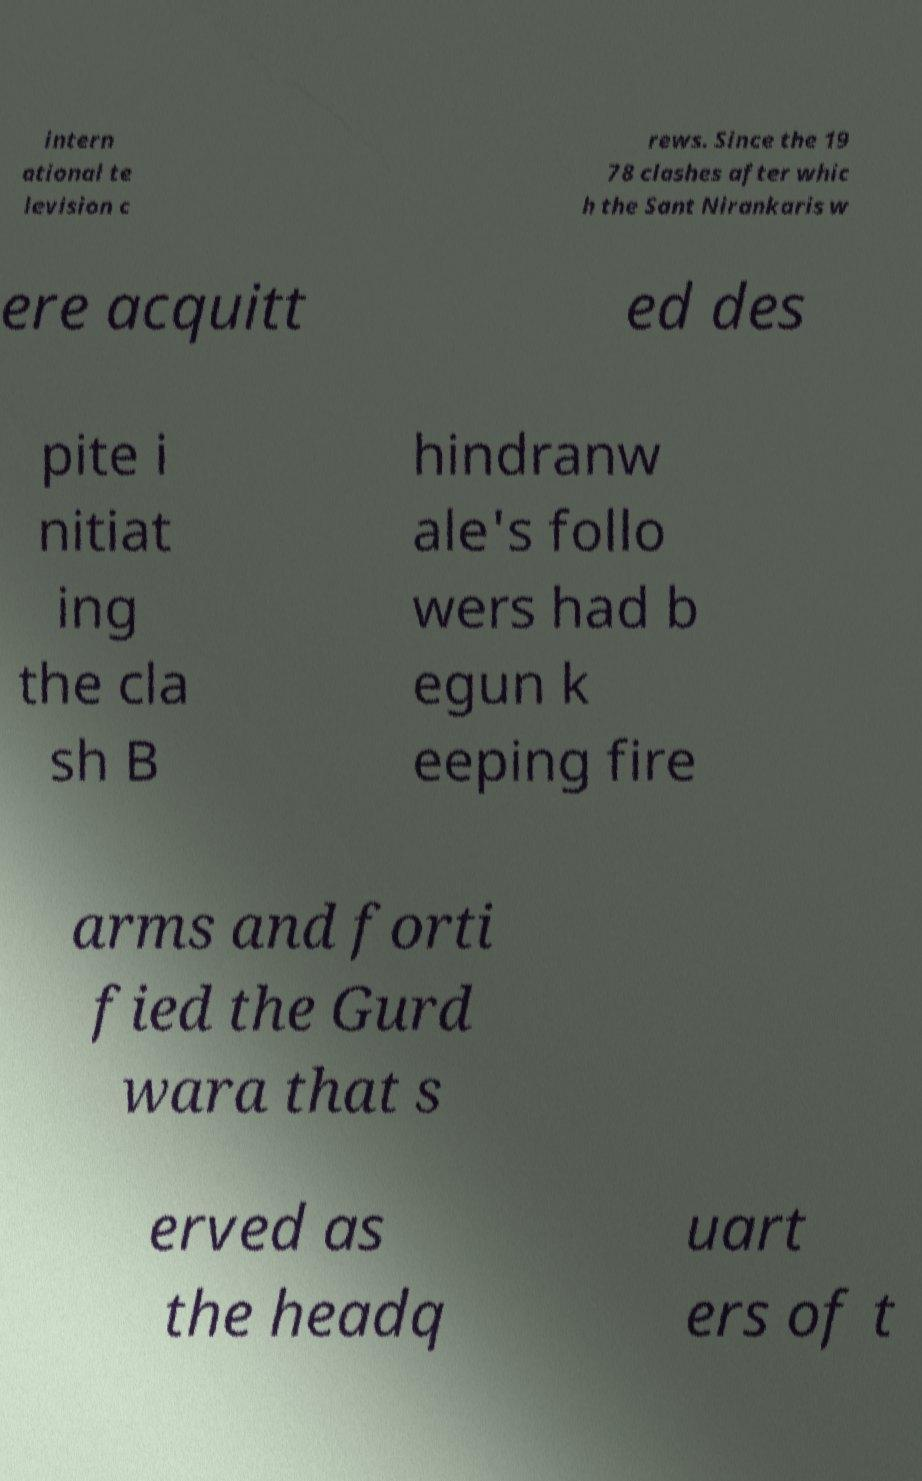Can you read and provide the text displayed in the image?This photo seems to have some interesting text. Can you extract and type it out for me? intern ational te levision c rews. Since the 19 78 clashes after whic h the Sant Nirankaris w ere acquitt ed des pite i nitiat ing the cla sh B hindranw ale's follo wers had b egun k eeping fire arms and forti fied the Gurd wara that s erved as the headq uart ers of t 